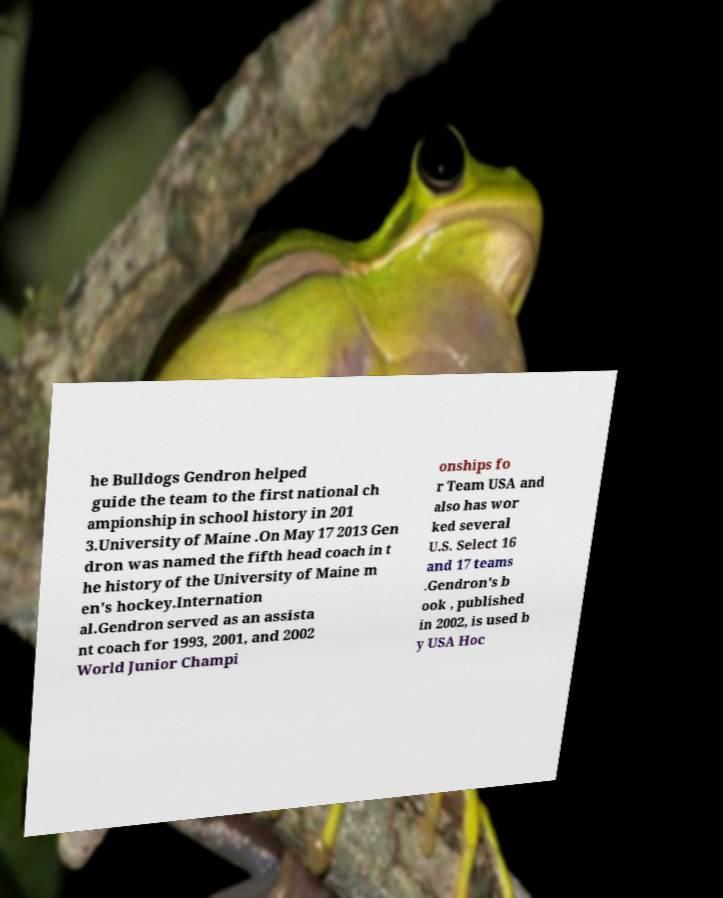Please identify and transcribe the text found in this image. he Bulldogs Gendron helped guide the team to the first national ch ampionship in school history in 201 3.University of Maine .On May 17 2013 Gen dron was named the fifth head coach in t he history of the University of Maine m en's hockey.Internation al.Gendron served as an assista nt coach for 1993, 2001, and 2002 World Junior Champi onships fo r Team USA and also has wor ked several U.S. Select 16 and 17 teams .Gendron's b ook , published in 2002, is used b y USA Hoc 